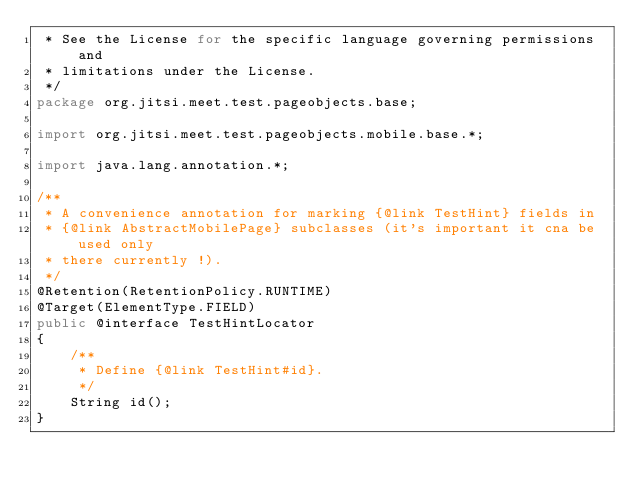<code> <loc_0><loc_0><loc_500><loc_500><_Java_> * See the License for the specific language governing permissions and
 * limitations under the License.
 */
package org.jitsi.meet.test.pageobjects.base;

import org.jitsi.meet.test.pageobjects.mobile.base.*;

import java.lang.annotation.*;

/**
 * A convenience annotation for marking {@link TestHint} fields in
 * {@link AbstractMobilePage} subclasses (it's important it cna be used only
 * there currently !).
 */
@Retention(RetentionPolicy.RUNTIME)
@Target(ElementType.FIELD)
public @interface TestHintLocator
{
    /**
     * Define {@link TestHint#id}.
     */
    String id();
}
</code> 